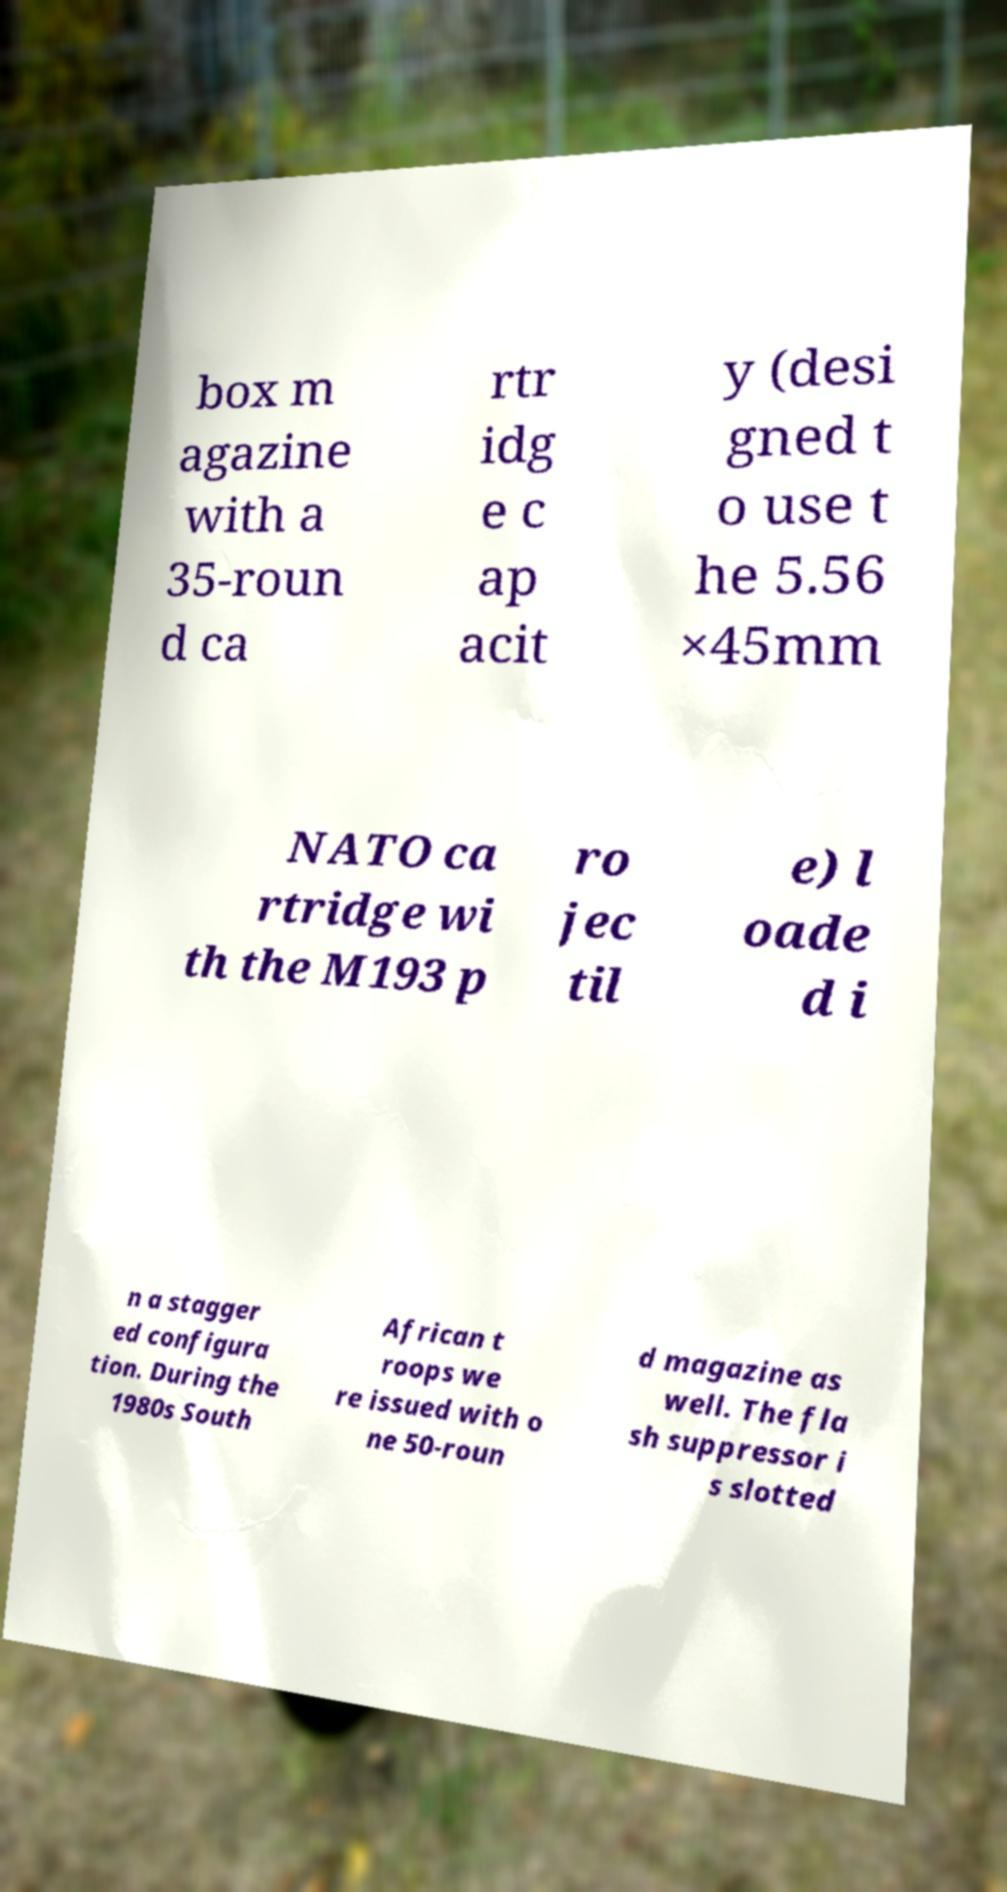Please identify and transcribe the text found in this image. box m agazine with a 35-roun d ca rtr idg e c ap acit y (desi gned t o use t he 5.56 ×45mm NATO ca rtridge wi th the M193 p ro jec til e) l oade d i n a stagger ed configura tion. During the 1980s South African t roops we re issued with o ne 50-roun d magazine as well. The fla sh suppressor i s slotted 